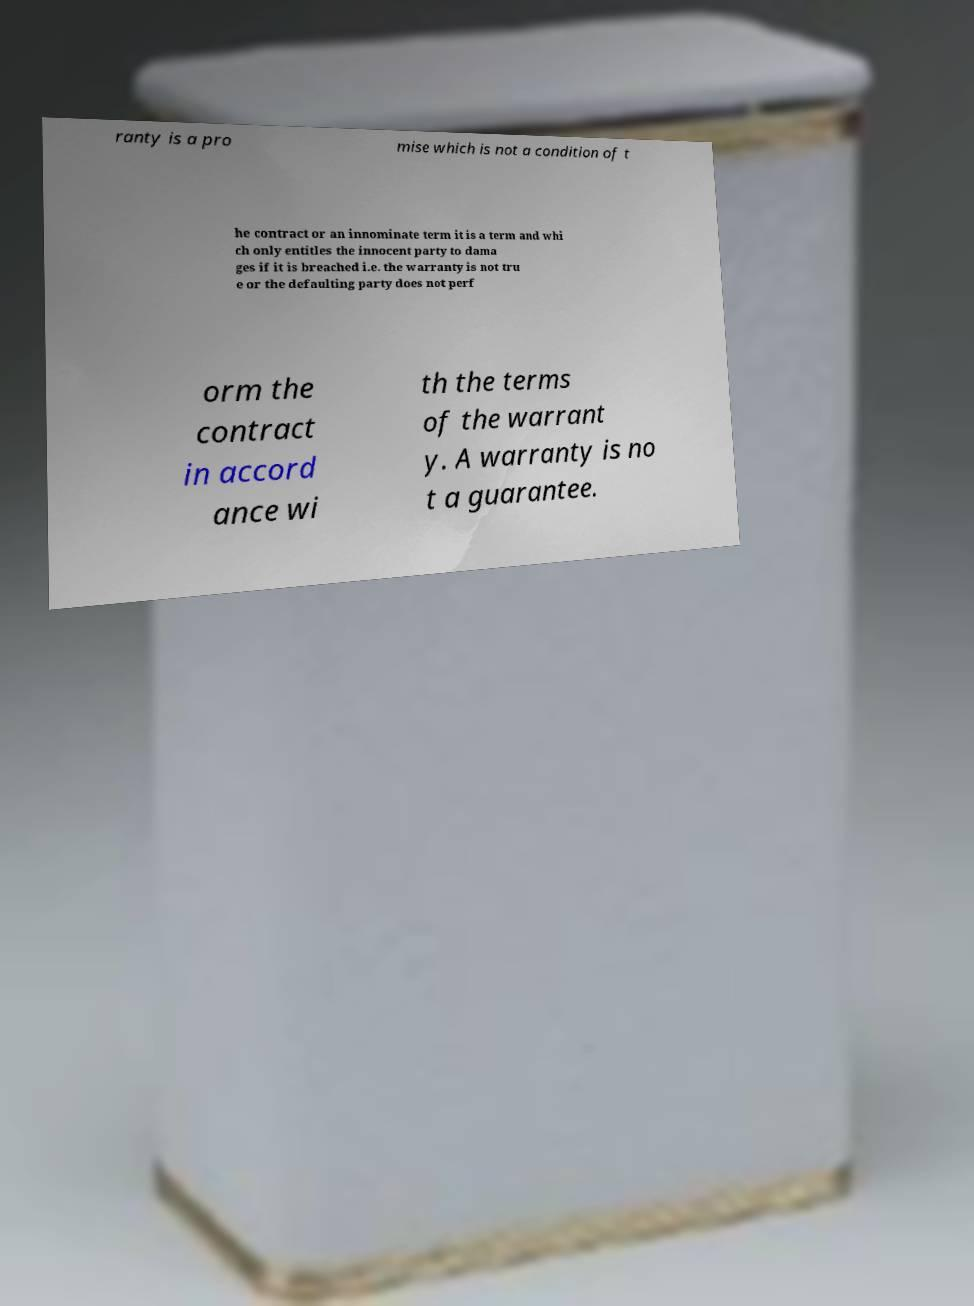Could you extract and type out the text from this image? ranty is a pro mise which is not a condition of t he contract or an innominate term it is a term and whi ch only entitles the innocent party to dama ges if it is breached i.e. the warranty is not tru e or the defaulting party does not perf orm the contract in accord ance wi th the terms of the warrant y. A warranty is no t a guarantee. 